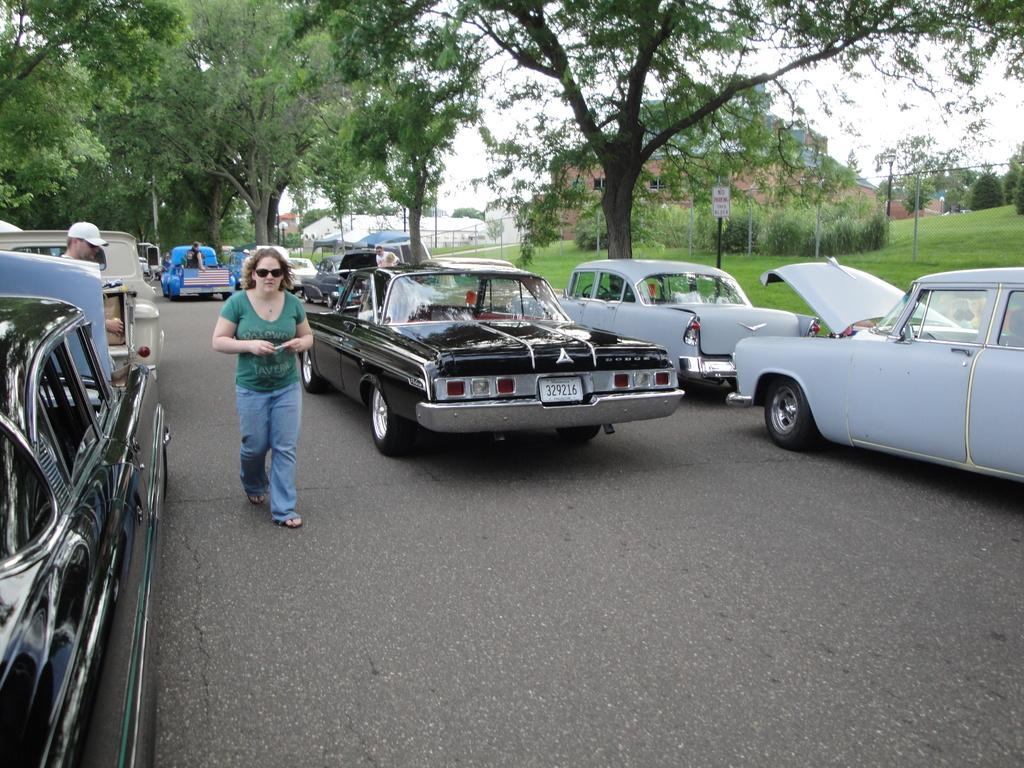What is happening on the road in the image? There are vehicles on the road in the image. Can you describe the people visible in the image? There are people visible in the image. What can be seen in the background of the image? There are trees, buildings, and the sky visible in the background of the image. Where is the ant located in the image? There is no ant present in the image. What type of alley can be seen in the image? There is no alley present in the image. 